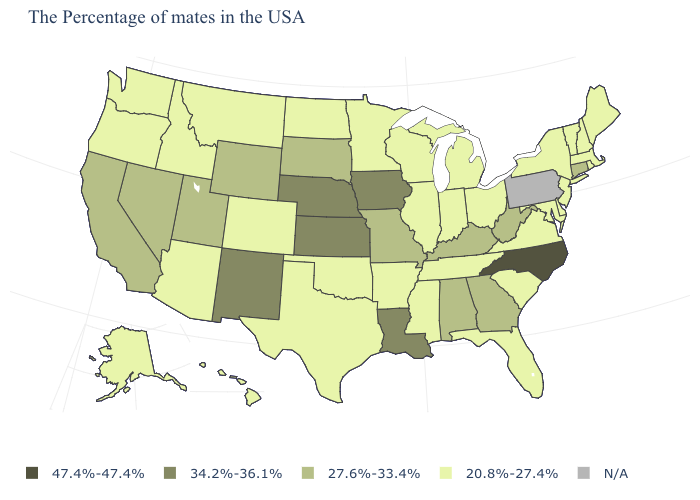What is the lowest value in states that border Ohio?
Keep it brief. 20.8%-27.4%. What is the value of Arkansas?
Answer briefly. 20.8%-27.4%. Is the legend a continuous bar?
Give a very brief answer. No. What is the value of Wyoming?
Keep it brief. 27.6%-33.4%. What is the value of Nevada?
Concise answer only. 27.6%-33.4%. What is the value of Texas?
Write a very short answer. 20.8%-27.4%. Name the states that have a value in the range 34.2%-36.1%?
Write a very short answer. Louisiana, Iowa, Kansas, Nebraska, New Mexico. Which states hav the highest value in the Northeast?
Write a very short answer. Connecticut. Name the states that have a value in the range N/A?
Write a very short answer. Pennsylvania. Name the states that have a value in the range 20.8%-27.4%?
Answer briefly. Maine, Massachusetts, Rhode Island, New Hampshire, Vermont, New York, New Jersey, Delaware, Maryland, Virginia, South Carolina, Ohio, Florida, Michigan, Indiana, Tennessee, Wisconsin, Illinois, Mississippi, Arkansas, Minnesota, Oklahoma, Texas, North Dakota, Colorado, Montana, Arizona, Idaho, Washington, Oregon, Alaska, Hawaii. Does Massachusetts have the lowest value in the USA?
Give a very brief answer. Yes. What is the highest value in the West ?
Give a very brief answer. 34.2%-36.1%. Name the states that have a value in the range 34.2%-36.1%?
Answer briefly. Louisiana, Iowa, Kansas, Nebraska, New Mexico. What is the lowest value in the MidWest?
Concise answer only. 20.8%-27.4%. 